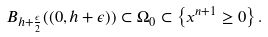Convert formula to latex. <formula><loc_0><loc_0><loc_500><loc_500>B _ { h + \frac { \epsilon } { 2 } } ( ( 0 , h + \epsilon ) ) \subset \Omega _ { 0 } \subset \left \{ x ^ { n + 1 } \geq 0 \right \} .</formula> 